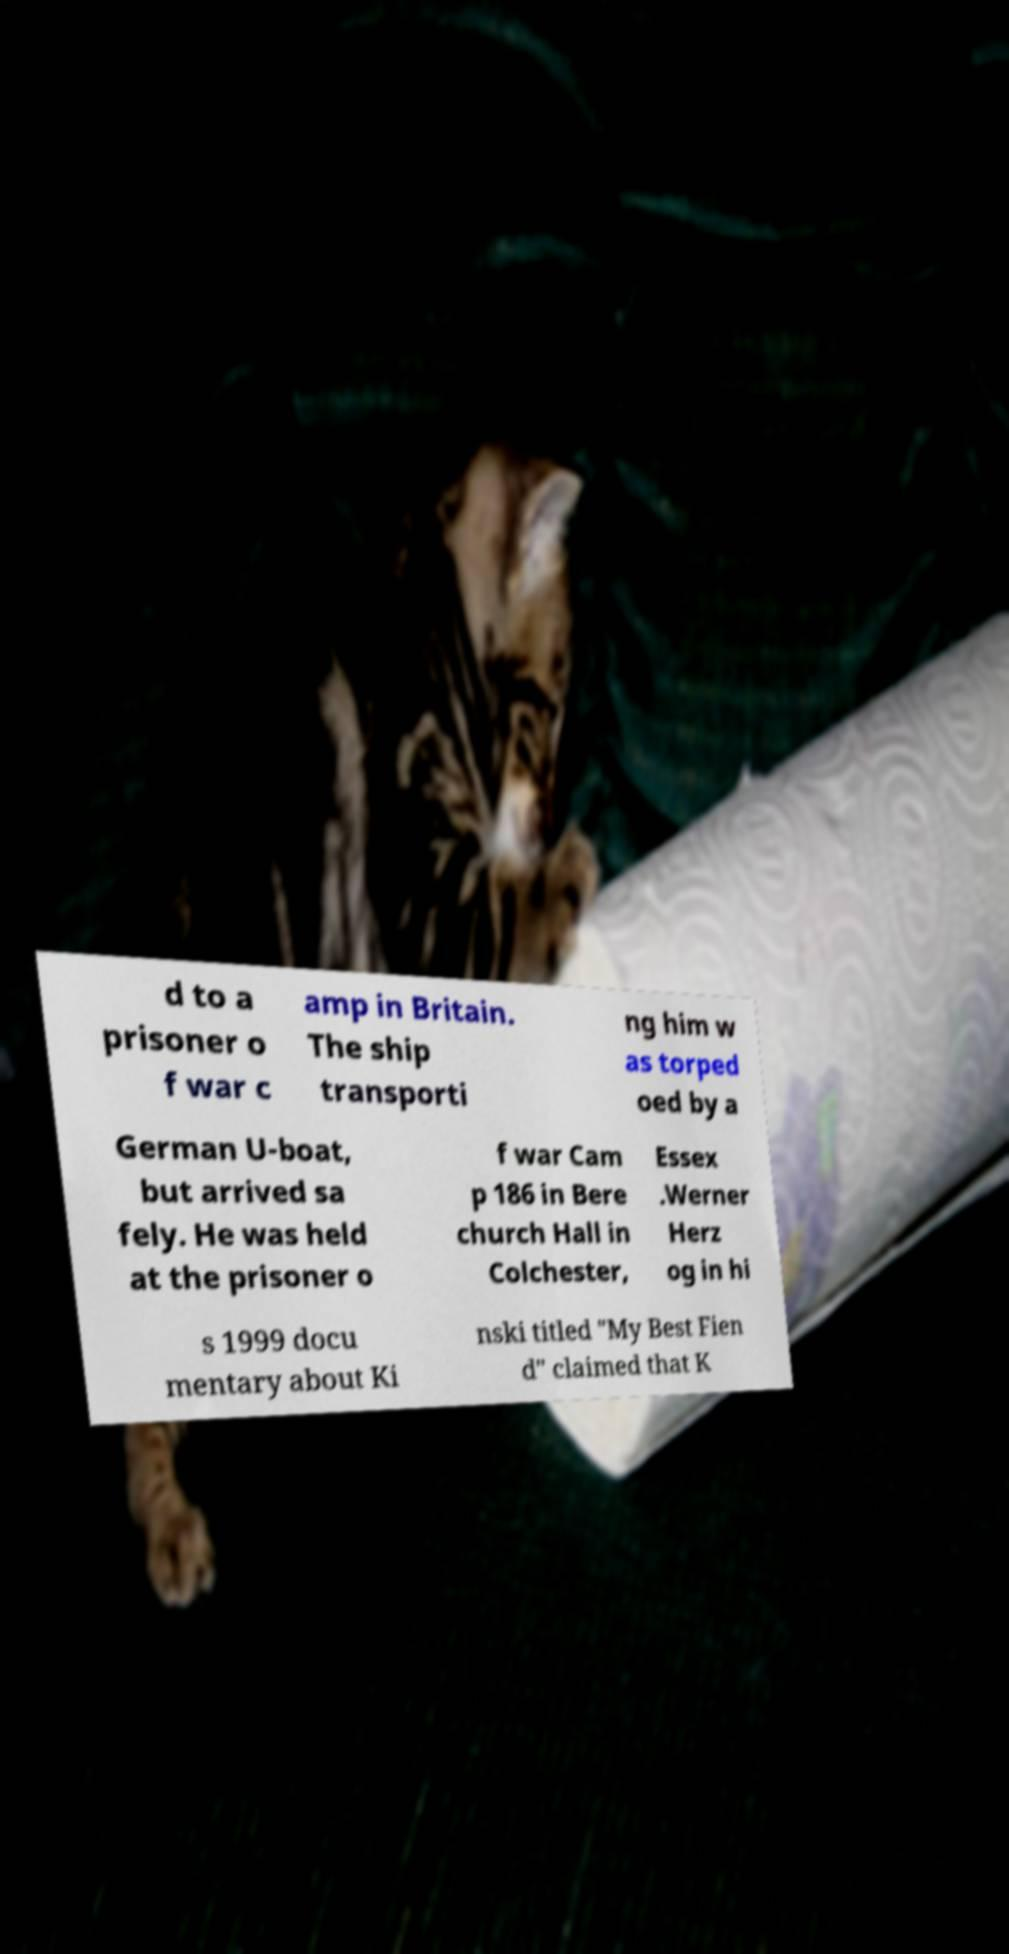Please read and relay the text visible in this image. What does it say? d to a prisoner o f war c amp in Britain. The ship transporti ng him w as torped oed by a German U-boat, but arrived sa fely. He was held at the prisoner o f war Cam p 186 in Bere church Hall in Colchester, Essex .Werner Herz og in hi s 1999 docu mentary about Ki nski titled "My Best Fien d" claimed that K 